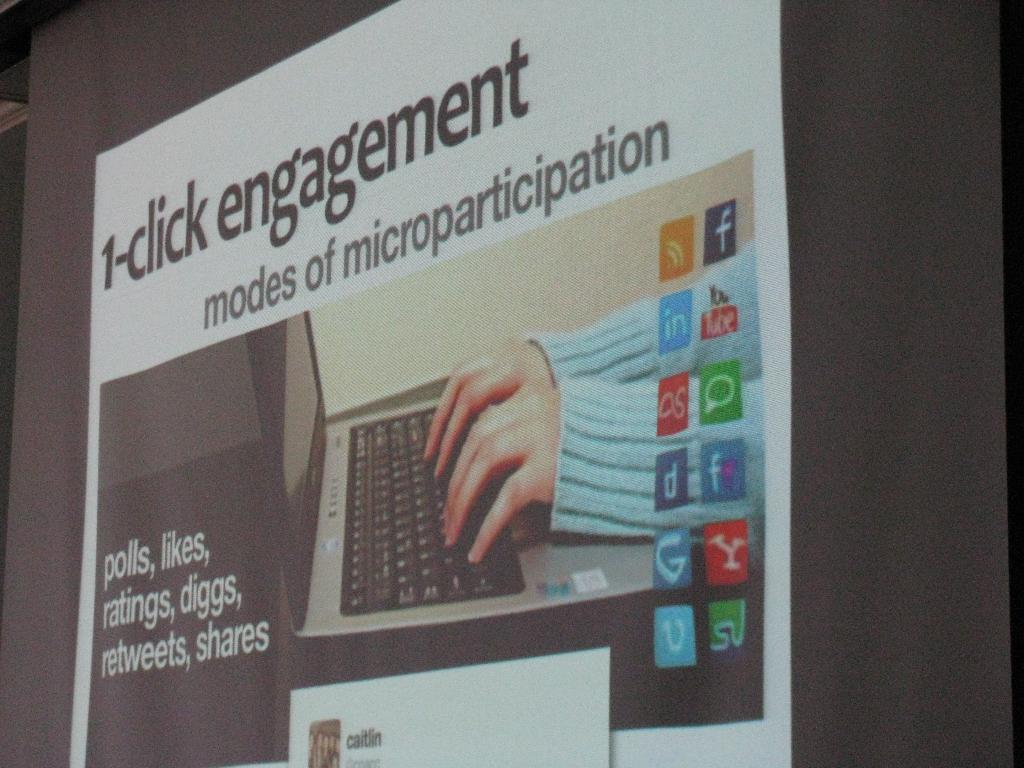Provide a one-sentence caption for the provided image. Information for modes of microparticipation called 1-click engagement. 